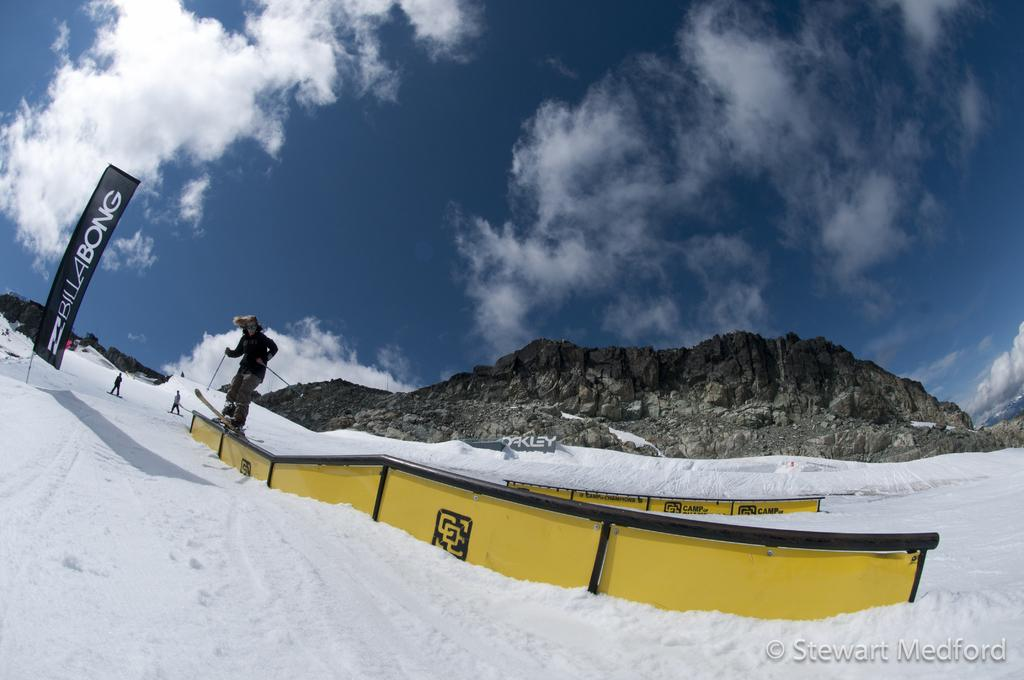Who or what is the main subject in the image? There is a person in the image. What is the person doing in the image? The person is standing on a ski board. What can be seen in the background of the image? There is a mountain and the sky visible in the background of the image. Can you describe the sky in the image? The sky is visible in the background of the image, and there is a cloud present. What is the ground made of in the image? There is snow in the image. What is the price of the party in the image? There is no party present in the image, so it is not possible to determine the price. 